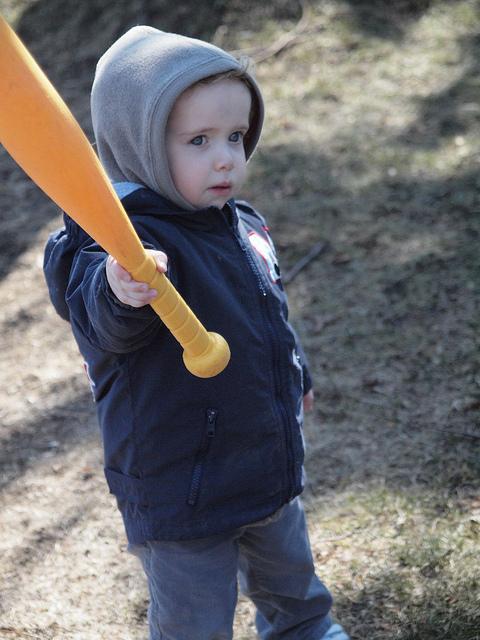What metal is the bat made out of?
Concise answer only. Plastic. What is the baby holding?
Concise answer only. Bat. What is the boy wearing around his neck?
Quick response, please. Coat. What is the child holding in his hand?
Write a very short answer. Bat. How old is the child?
Answer briefly. 3. What is the bat made out of?
Be succinct. Plastic. 